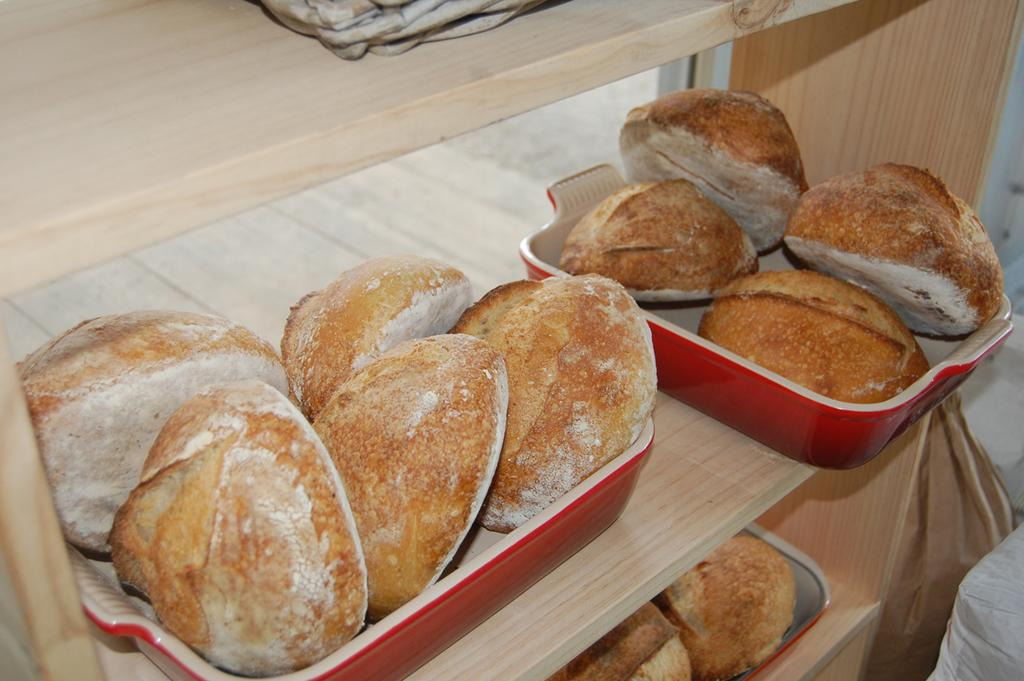What can be seen in the containers in the image? There are food items in containers in the image. Where are the bags located in the image? The bags are in the bottom right of the image. What type of pet can be seen in the image? There is no pet visible in the image. What time is it according to the clock in the image? There is no clock present in the image. 